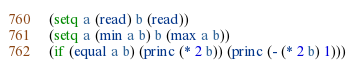Convert code to text. <code><loc_0><loc_0><loc_500><loc_500><_Lisp_>(setq a (read) b (read))
(setq a (min a b) b (max a b))
(if (equal a b) (princ (* 2 b)) (princ (- (* 2 b) 1)))</code> 